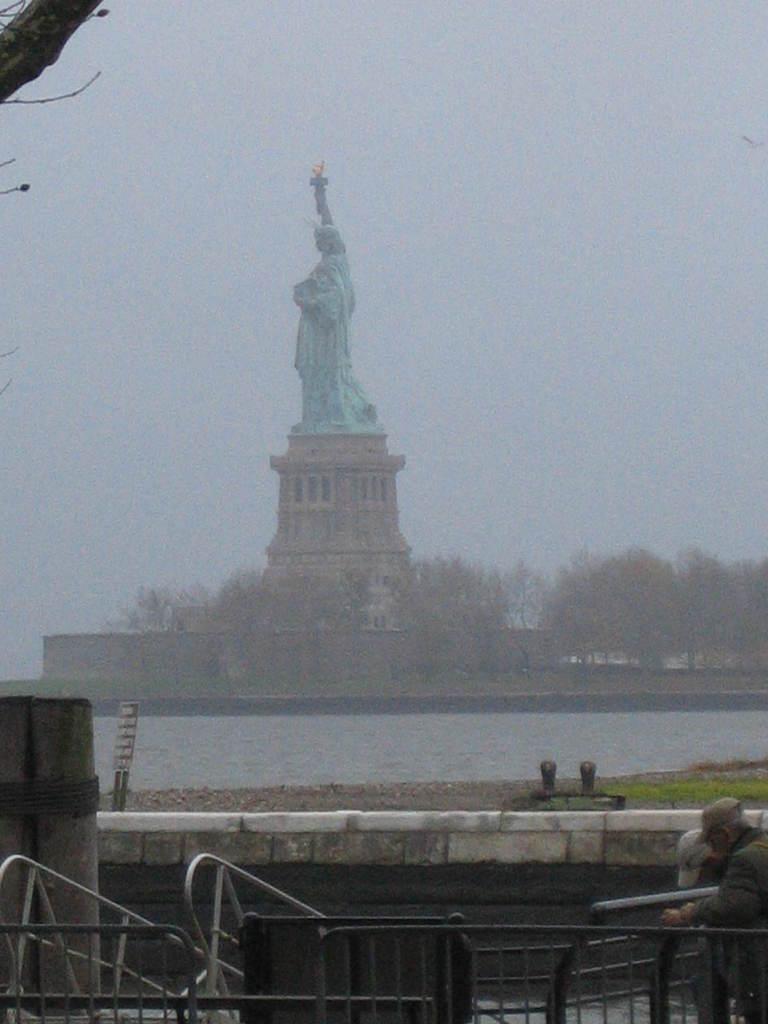Describe this image in one or two sentences. At the bottom of the picture, we see men standing beside the iron railing. Behind them, we see the grass and a board. In the middle of the picture, we see the statue of the liberty. In the background, there are trees and buildings. At the top of the picture, we see the sky. 